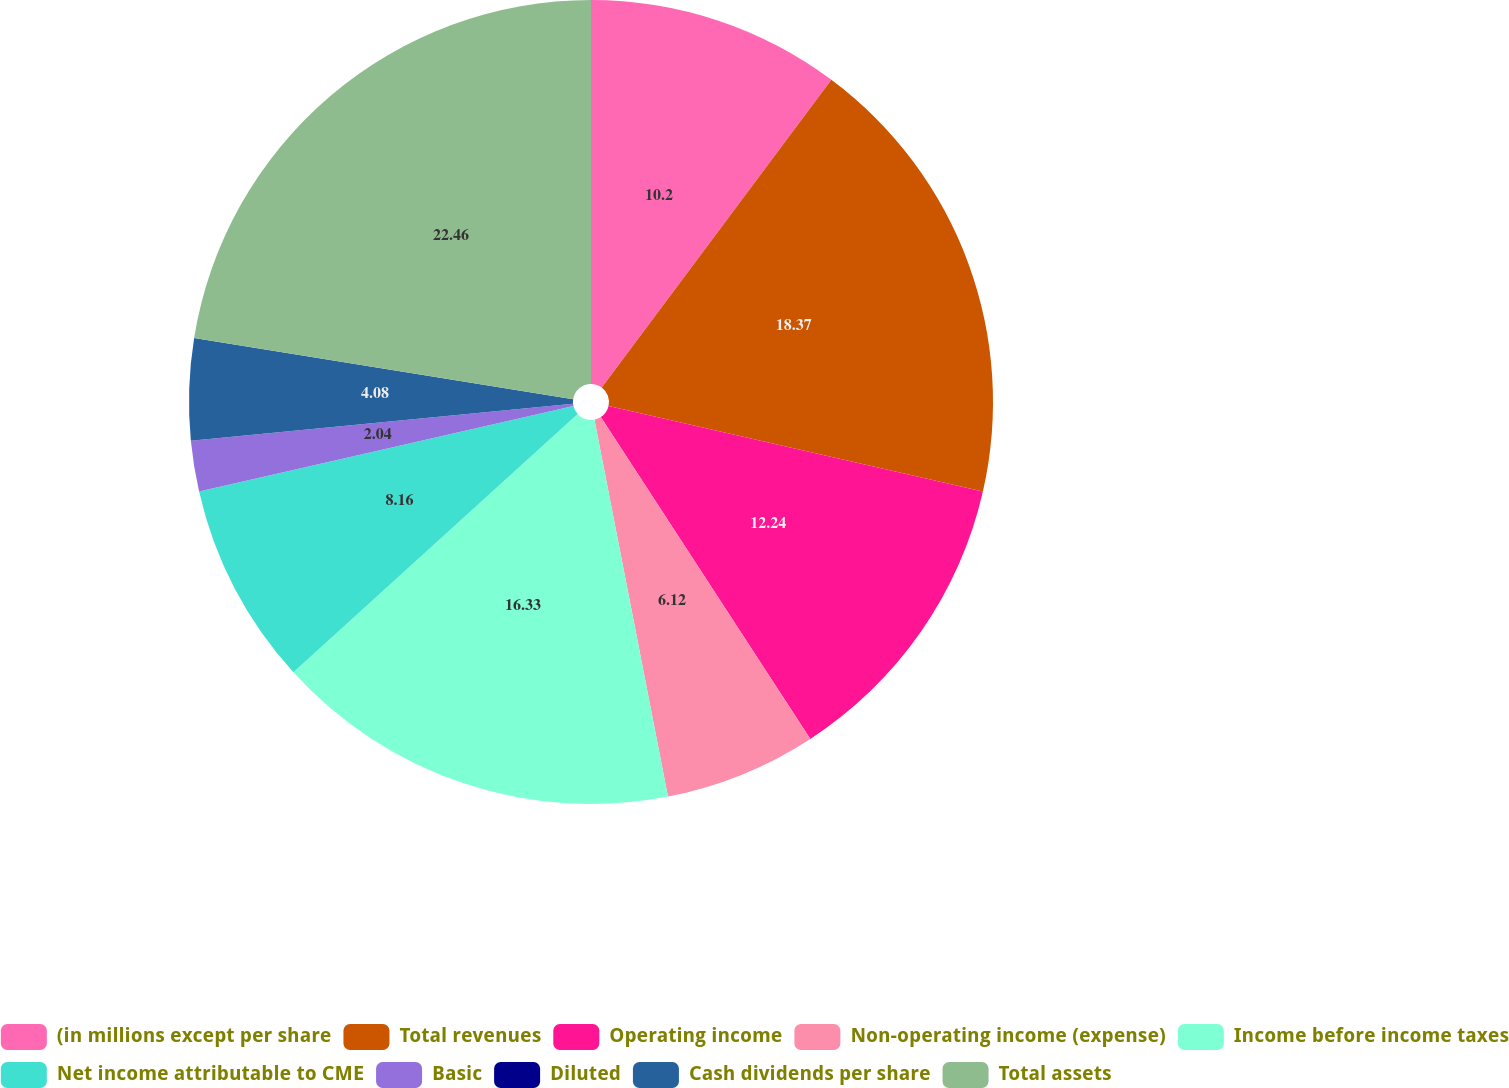Convert chart. <chart><loc_0><loc_0><loc_500><loc_500><pie_chart><fcel>(in millions except per share<fcel>Total revenues<fcel>Operating income<fcel>Non-operating income (expense)<fcel>Income before income taxes<fcel>Net income attributable to CME<fcel>Basic<fcel>Diluted<fcel>Cash dividends per share<fcel>Total assets<nl><fcel>10.2%<fcel>18.37%<fcel>12.24%<fcel>6.12%<fcel>16.33%<fcel>8.16%<fcel>2.04%<fcel>0.0%<fcel>4.08%<fcel>22.45%<nl></chart> 